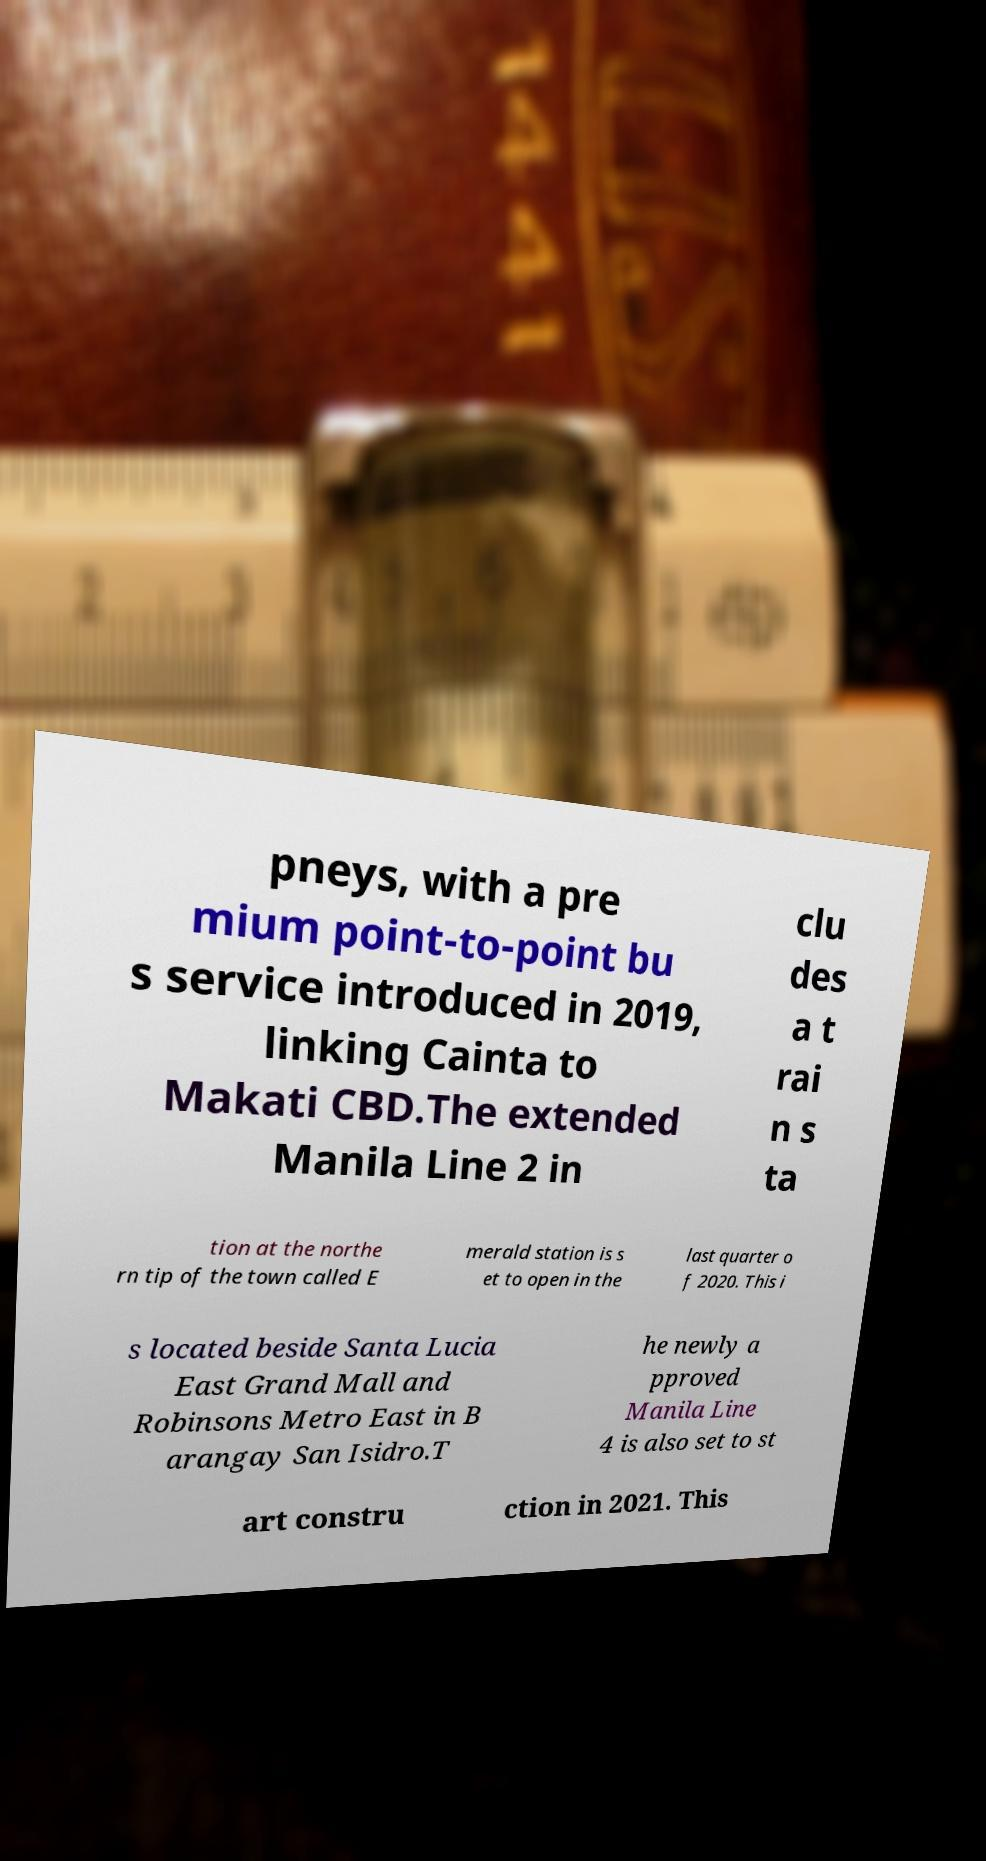Can you accurately transcribe the text from the provided image for me? pneys, with a pre mium point-to-point bu s service introduced in 2019, linking Cainta to Makati CBD.The extended Manila Line 2 in clu des a t rai n s ta tion at the northe rn tip of the town called E merald station is s et to open in the last quarter o f 2020. This i s located beside Santa Lucia East Grand Mall and Robinsons Metro East in B arangay San Isidro.T he newly a pproved Manila Line 4 is also set to st art constru ction in 2021. This 